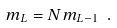<formula> <loc_0><loc_0><loc_500><loc_500>m _ { L } = N m _ { L - 1 } \ .</formula> 